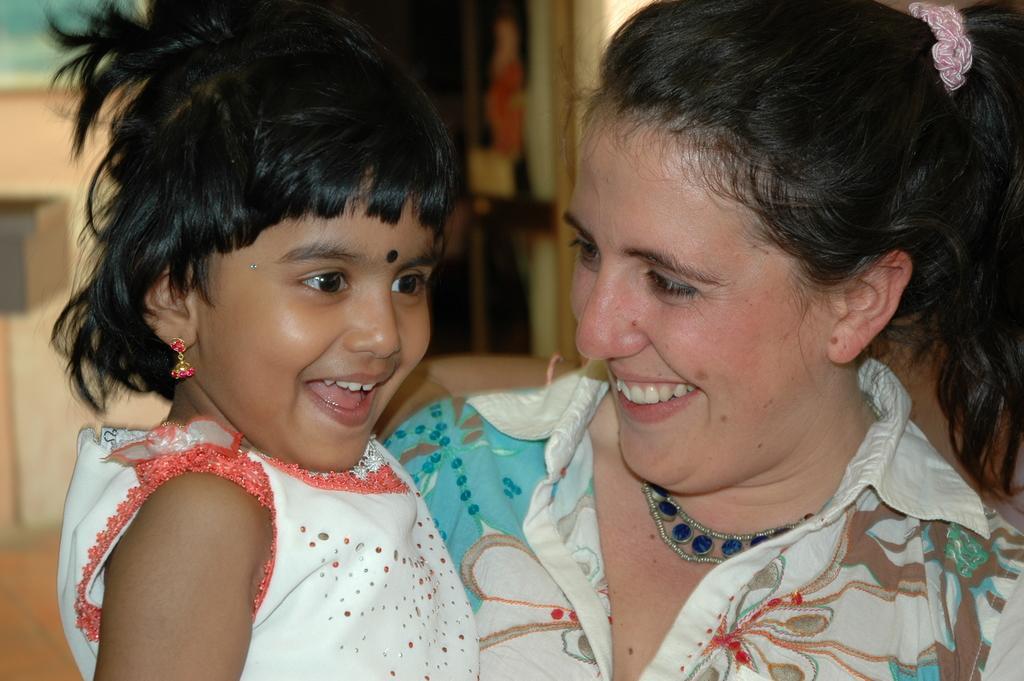Describe this image in one or two sentences. In this image, I can see a woman and a girl smiling. There is a blurred background. 